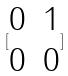<formula> <loc_0><loc_0><loc_500><loc_500>[ \begin{matrix} 0 & 1 \\ 0 & 0 \end{matrix} ]</formula> 